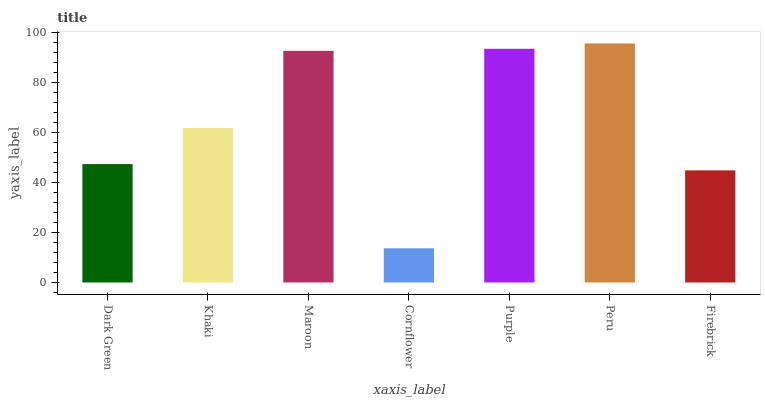Is Cornflower the minimum?
Answer yes or no. Yes. Is Peru the maximum?
Answer yes or no. Yes. Is Khaki the minimum?
Answer yes or no. No. Is Khaki the maximum?
Answer yes or no. No. Is Khaki greater than Dark Green?
Answer yes or no. Yes. Is Dark Green less than Khaki?
Answer yes or no. Yes. Is Dark Green greater than Khaki?
Answer yes or no. No. Is Khaki less than Dark Green?
Answer yes or no. No. Is Khaki the high median?
Answer yes or no. Yes. Is Khaki the low median?
Answer yes or no. Yes. Is Dark Green the high median?
Answer yes or no. No. Is Peru the low median?
Answer yes or no. No. 